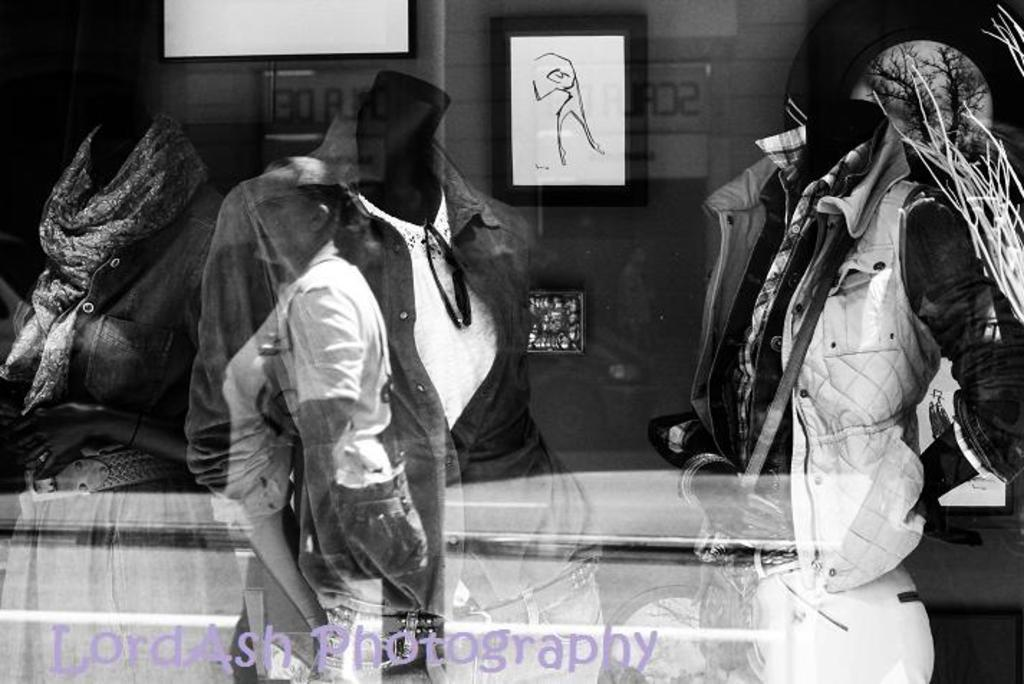What can be seen in the image due to reflection? There is a reflection of people and a building in the image. Can you describe the reflection of the people in the image? The reflection of people in the image shows their presence and position relative to the reflective surface. What else can be observed about the reflection of the building in the image? The reflection of the building in the image provides a clear view of its structure and details. How does the butter stem from the image? There is no butter or stem present in the image; it only features reflections of people and a building. 